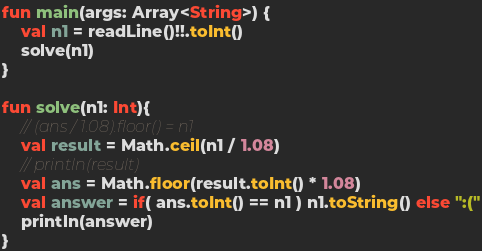Convert code to text. <code><loc_0><loc_0><loc_500><loc_500><_Kotlin_>fun main(args: Array<String>) {
    val n1 = readLine()!!.toInt()
    solve(n1)
}

fun solve(n1: Int){
    // (ans / 1.08).floor() = n1
    val result = Math.ceil(n1 / 1.08)
    // println(result)
    val ans = Math.floor(result.toInt() * 1.08)
    val answer = if( ans.toInt() == n1 ) n1.toString() else ":("
    println(answer)
}</code> 